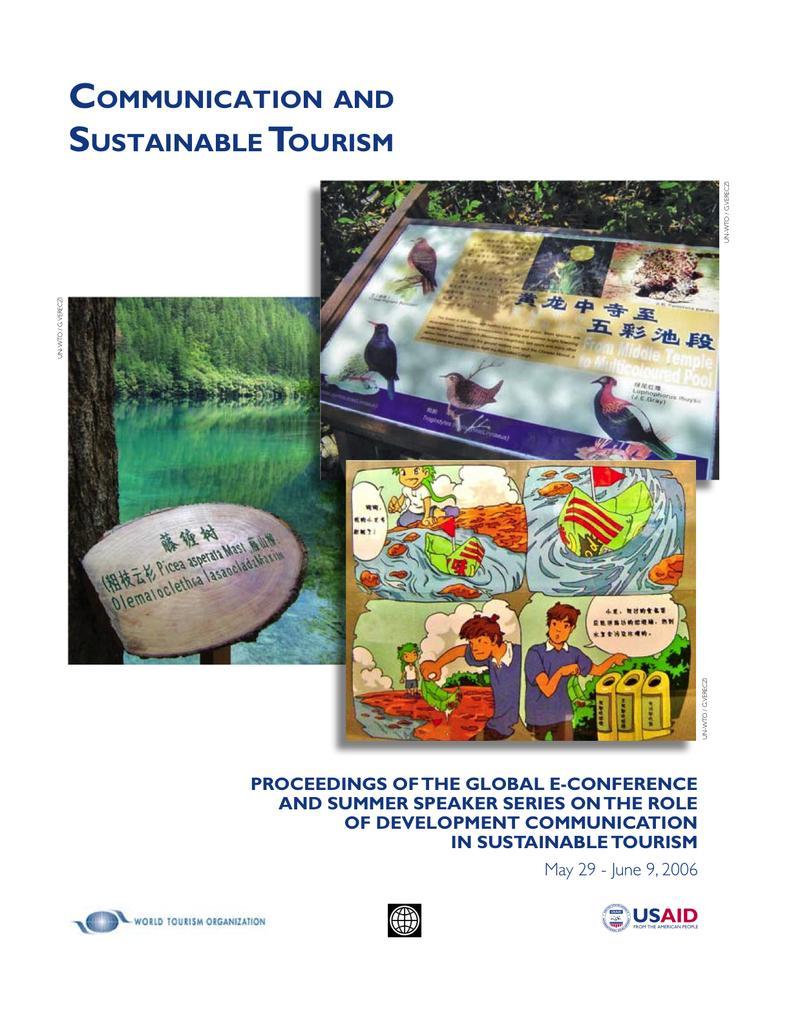Could you give a brief overview of what you see in this image? In this image, we can see some posters with text and images. We can also see some text. 